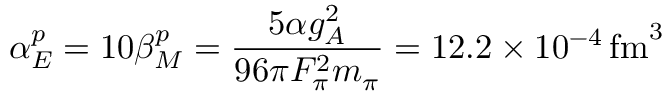Convert formula to latex. <formula><loc_0><loc_0><loc_500><loc_500>\alpha _ { E } ^ { p } = 1 0 \beta _ { M } ^ { p } = { \frac { 5 \alpha g _ { A } ^ { 2 } } { 9 6 \pi F _ { \pi } ^ { 2 } m _ { \pi } } } = 1 2 . 2 \times 1 0 ^ { - 4 } \, f m ^ { 3 }</formula> 